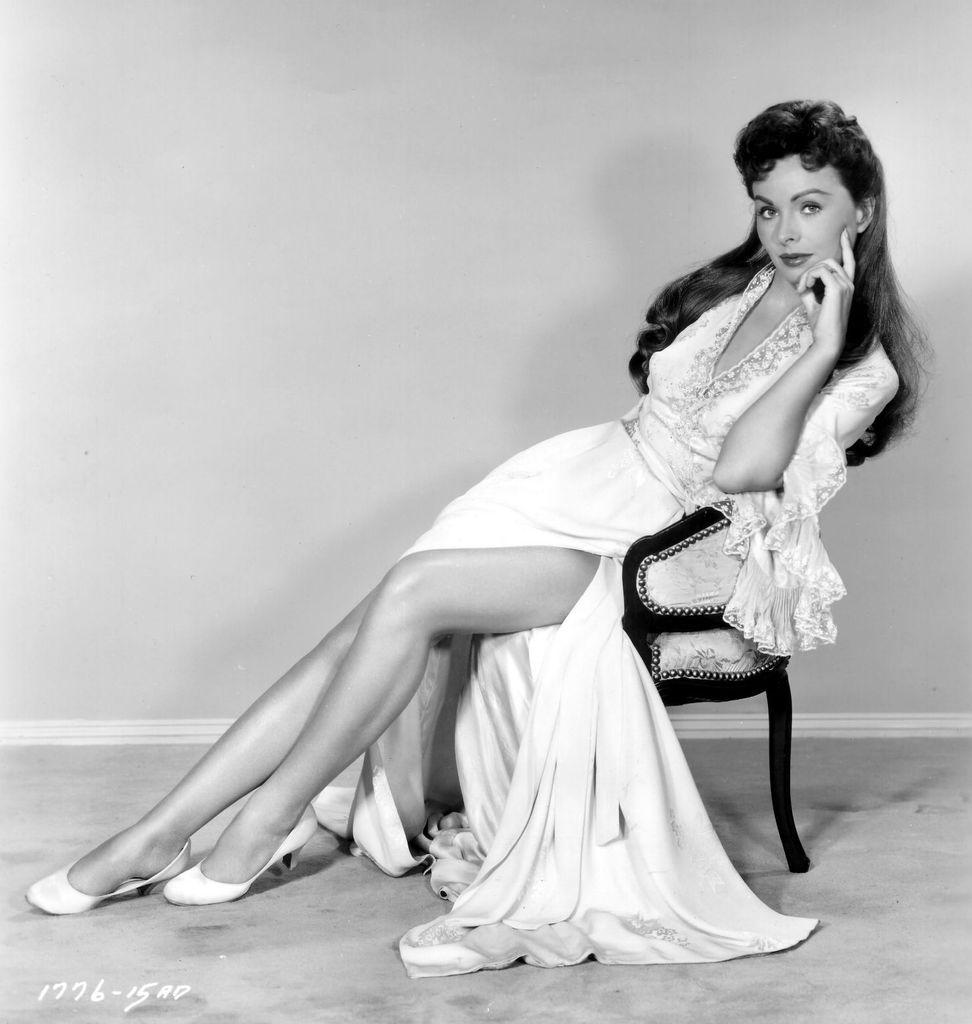What is the color scheme of the image? The image is in black and white. Who is present in the image? There is a woman in the image. What is the woman doing in the image? The woman is sitting on a chair. What is the woman wearing in the image? The woman is wearing a long frock. Can you see the woman's desire for a new nest in the image? There is no mention of a nest or desire in the image, as it features a woman sitting on a chair while wearing a long frock. 